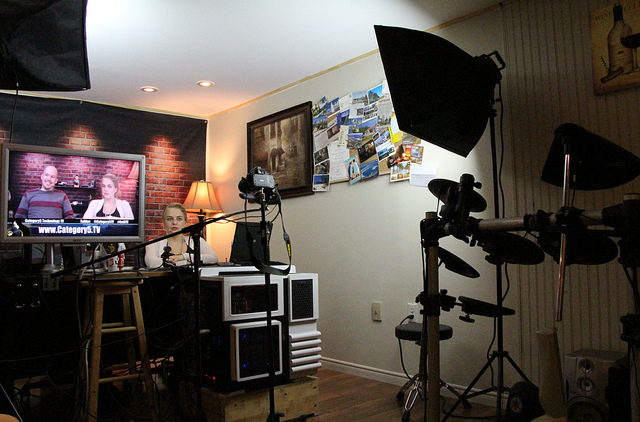Read and extract the text from this image. WWW.Category5.TV 